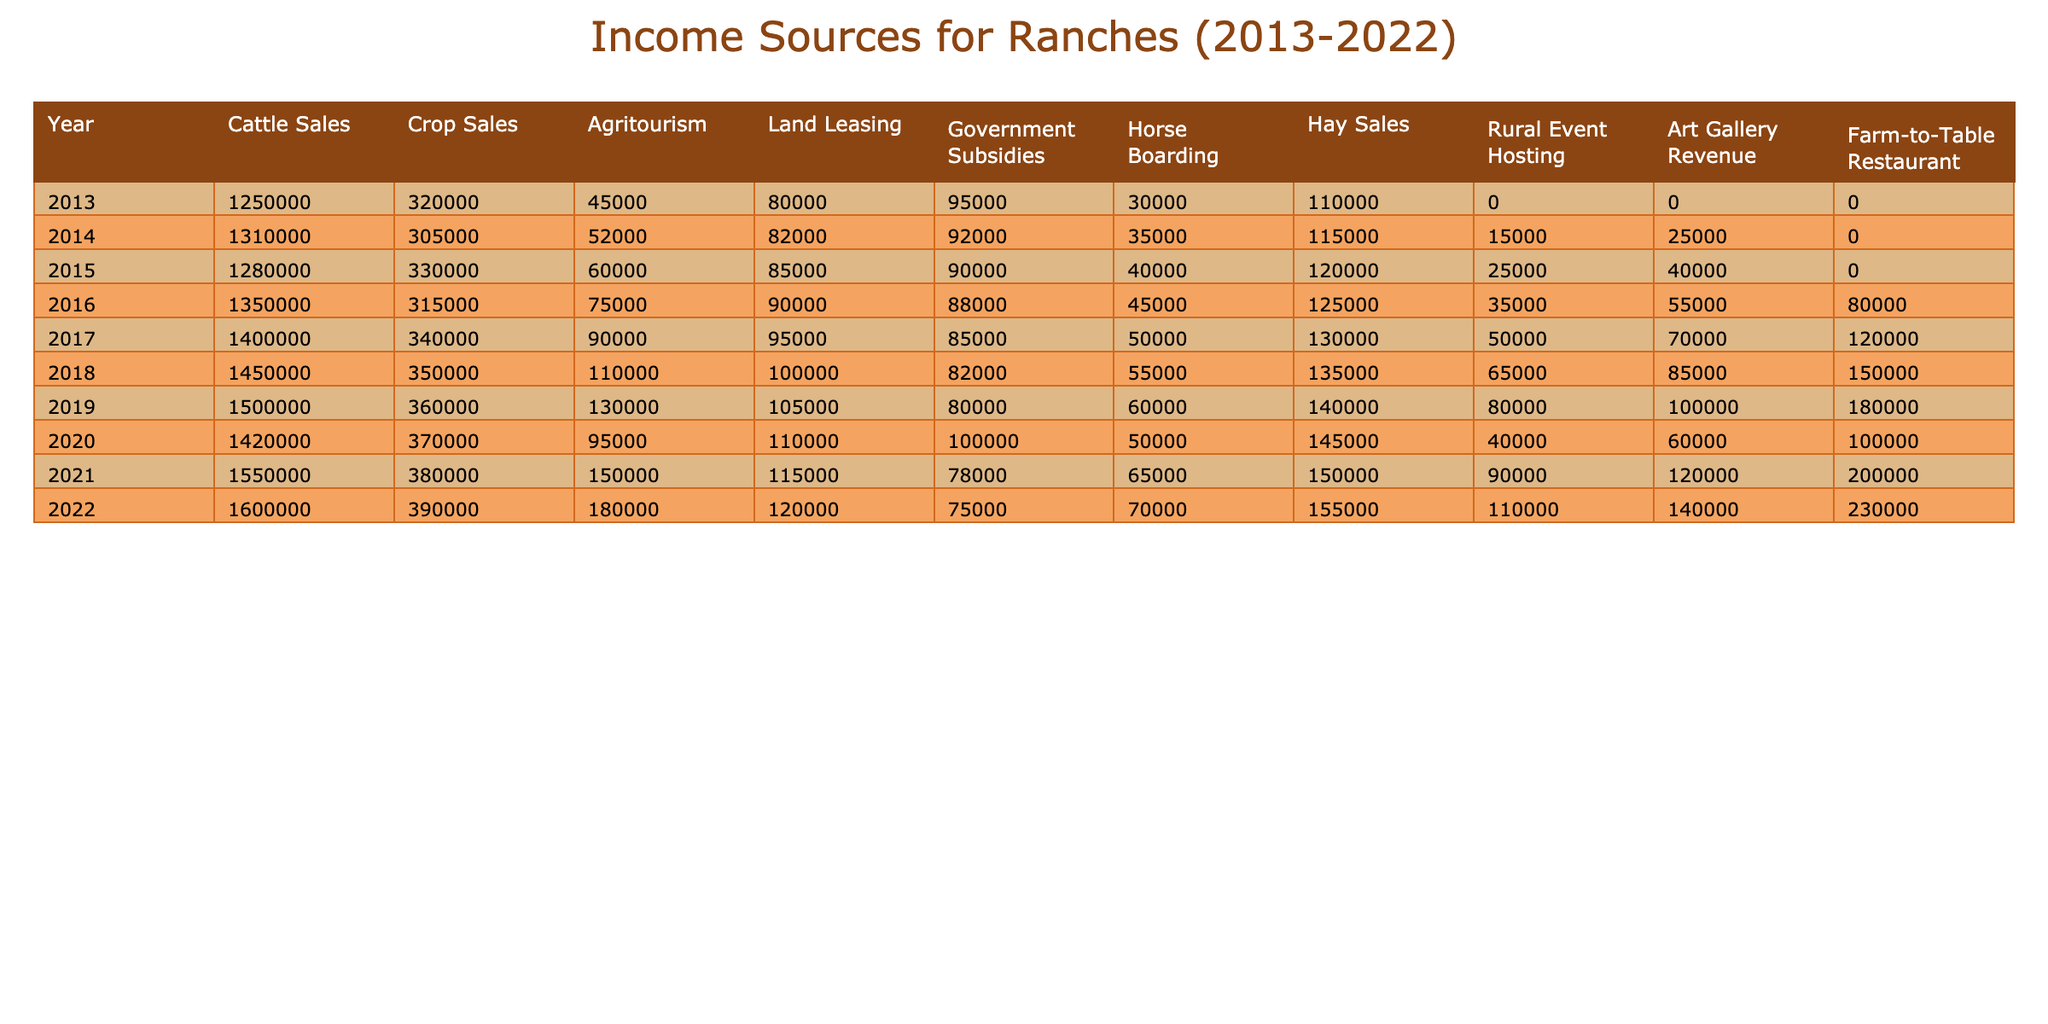What was the total income from Cattle Sales across the decade? To find the total income from Cattle Sales, we sum the values from each year: (1250000 + 1310000 + 1280000 + 1350000 + 1400000 + 1450000 + 1500000 + 1420000 + 1550000 + 1600000) = 13950000.
Answer: 13950000 In which year did Agritourism generate the highest income? The highest income from Agritourism can be identified by looking at the values directly in the table. The maximum value occurred in 2022 with an income of 180000.
Answer: 2022 What is the average revenue from Horse Boarding over the decade? To find the average, we sum the Horse Boarding revenue from each year: (30000 + 35000 + 40000 + 45000 + 50000 + 55000 + 60000 + 50000 + 65000 + 70000) = 475000; then divide by the number of years (10): 475000/10 = 47500.
Answer: 47500 Did Land Leasing income increase every year? To verify, compare the Land Leasing income year by year: 80000, 82000, 85000, 90000, 95000, 100000, 105000, 110000, 115000, 120000. There is no decrease in income in any year, so the answer is yes.
Answer: Yes What was the total revenue from the Farm-to-Table Restaurant in 2021 and 2022 combined? We find the revenue for both years: in 2021 it's 200000 and in 2022 it's 230000. Adding these together: 200000 + 230000 = 430000.
Answer: 430000 How much more did Cattle Sales yield in 2019 compared to 2013? The income for Cattle Sales in 2019 was 1500000 and in 2013 it was 1250000. We compute the difference: 1500000 - 1250000 = 250000.
Answer: 250000 What percentage of revenue did Government Subsidies contribute to total income in 2016? First, calculate total income for 2016 by adding up all sources: 1350000 + 315000 + 75000 + 90000 + 88000 + 45000 + 125000 + 35000 + 55000 + 80000 = 1865000. Then calculate the percentage: (90000 / 1865000) * 100 ≈ 4.82%.
Answer: Approximately 4.82% Which income source showed the most significant growth from 2013 to 2022? Determine the difference for each income source from 2013 to 2022: Cattle Sales grew by 350000, Crop Sales grew by 70000, Agritourism grew by 135000, etc. The greatest increase is Cattle Sales.
Answer: Cattle Sales What was the trend in income for Rural Event Hosting between 2013 and 2022? In 2013, Rural Event Hosting had income of 0, which increased each year to reach 110000 in 2022. Therefore, the trend indicates consistent growth.
Answer: Consistent growth Which category had the lowest income in 2018? By examining the income values for all categories in 2018, we identify that the lowest income was from Art Gallery Revenue, which was 85000.
Answer: Art Gallery Revenue 